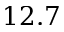<formula> <loc_0><loc_0><loc_500><loc_500>1 2 . 7</formula> 